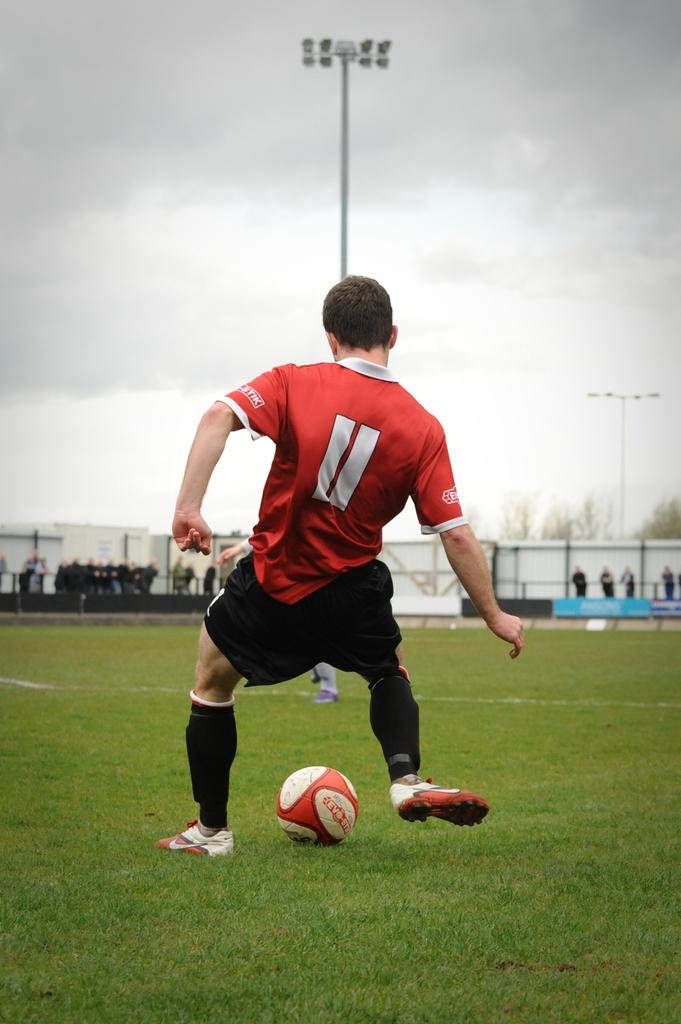Provide a one-sentence caption for the provided image. The number 11 is displayed on the shirt of a soccer player. 